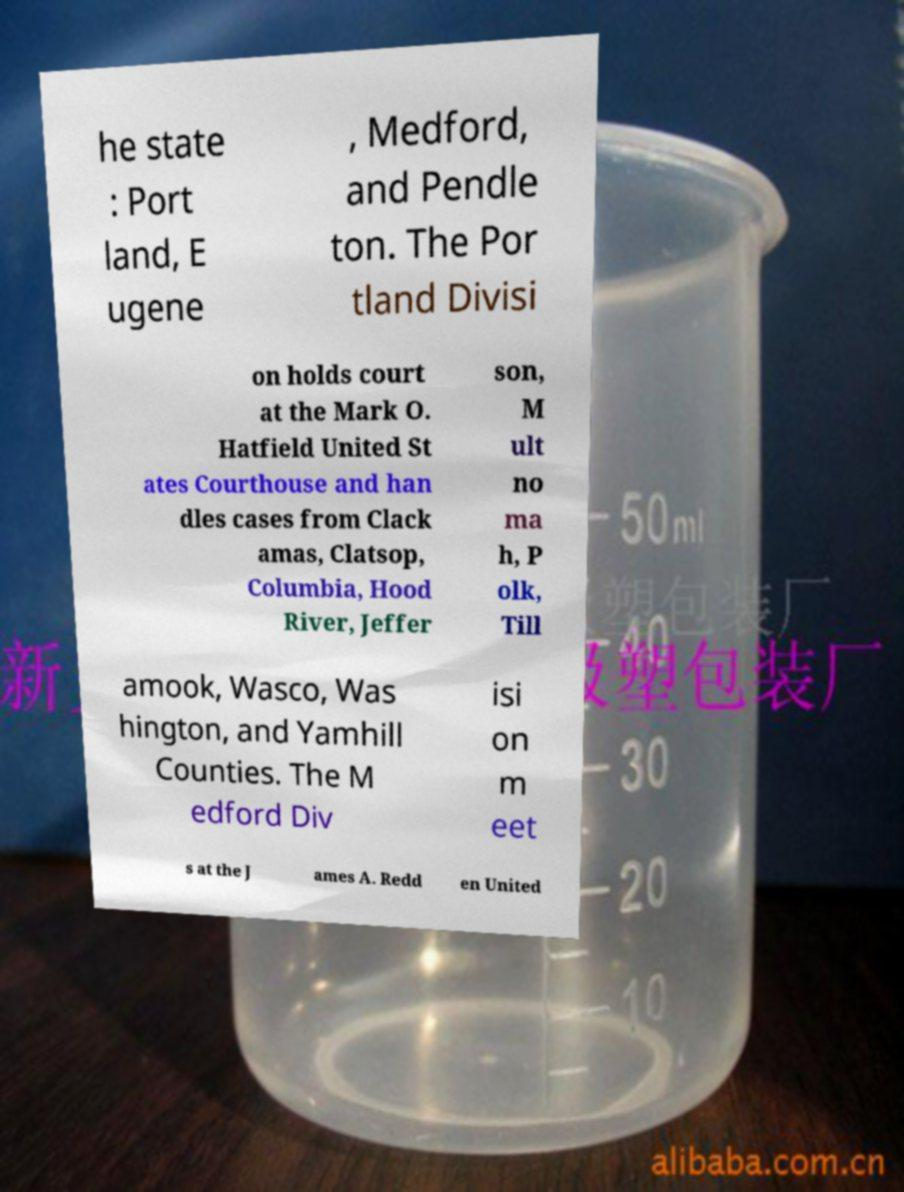Please identify and transcribe the text found in this image. he state : Port land, E ugene , Medford, and Pendle ton. The Por tland Divisi on holds court at the Mark O. Hatfield United St ates Courthouse and han dles cases from Clack amas, Clatsop, Columbia, Hood River, Jeffer son, M ult no ma h, P olk, Till amook, Wasco, Was hington, and Yamhill Counties. The M edford Div isi on m eet s at the J ames A. Redd en United 